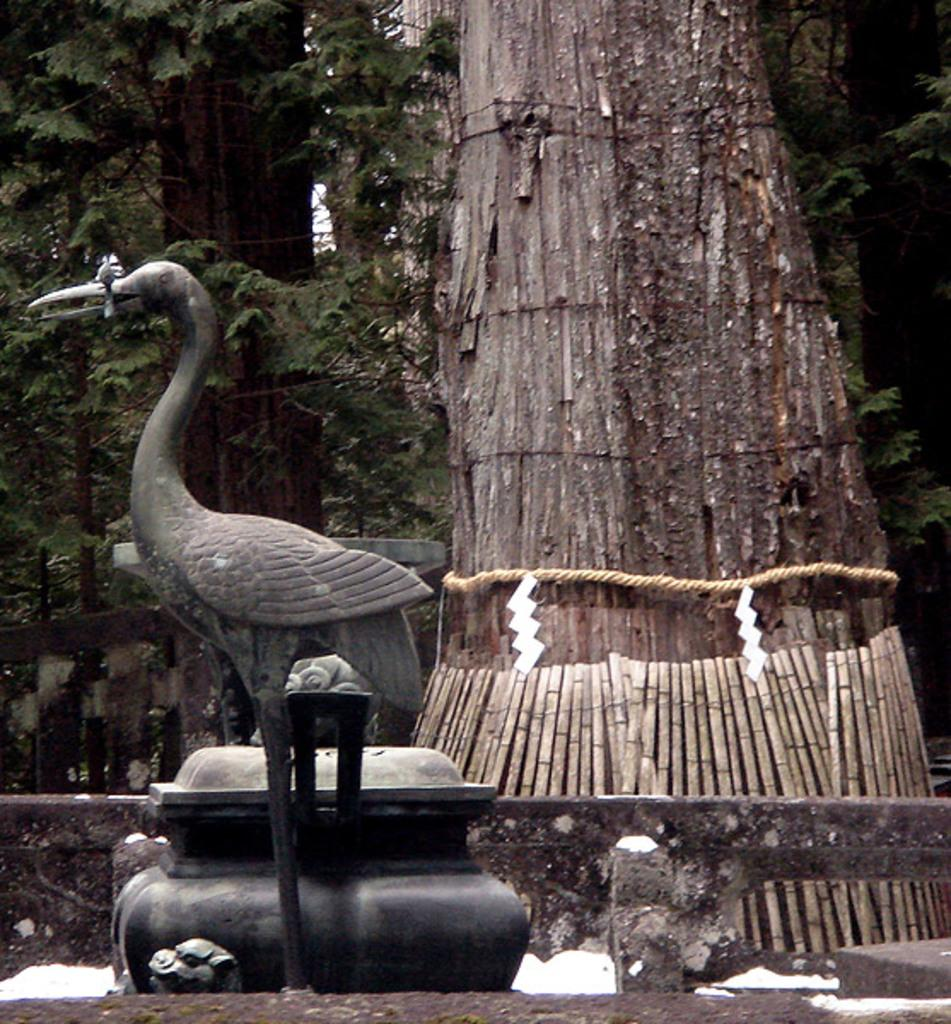What is located on the left side of the image? There is a statue of a bird and trees on the left side of the image. What can be seen on the right side of the image? There is a tree on the right side of the image. What is attached to the tree on the right side of the image? A rope is tied to the tree on the right side of the image. What type of wine is being served in the image? There is no wine present in the image; it features a statue of a bird, trees, and a rope tied to a tree. What kind of earth can be seen in the image? The image does not show any earth or soil; it primarily features a statue, trees, and a rope tied to a tree. 